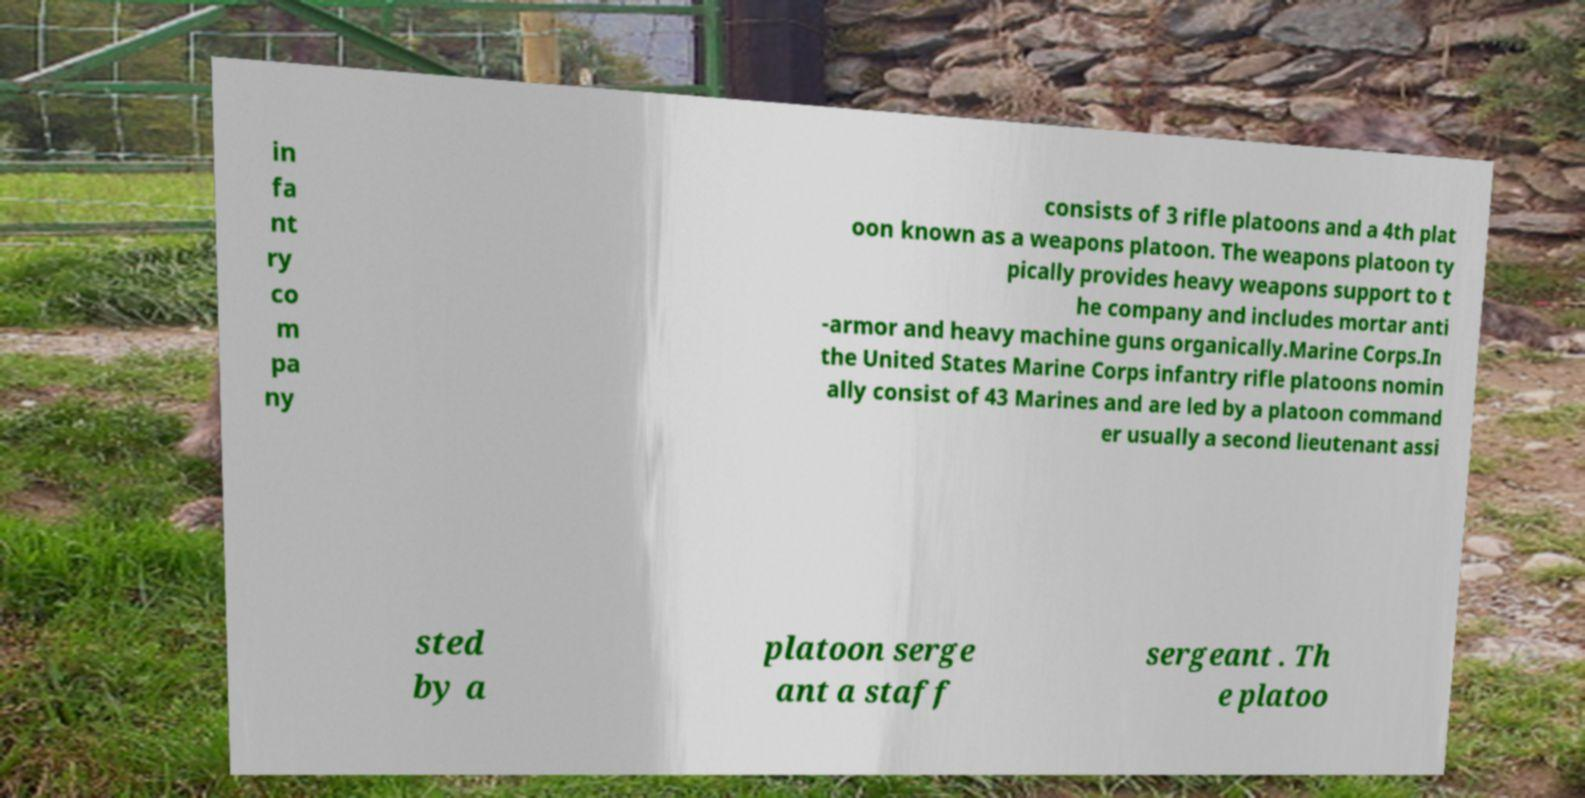Could you extract and type out the text from this image? in fa nt ry co m pa ny consists of 3 rifle platoons and a 4th plat oon known as a weapons platoon. The weapons platoon ty pically provides heavy weapons support to t he company and includes mortar anti -armor and heavy machine guns organically.Marine Corps.In the United States Marine Corps infantry rifle platoons nomin ally consist of 43 Marines and are led by a platoon command er usually a second lieutenant assi sted by a platoon serge ant a staff sergeant . Th e platoo 